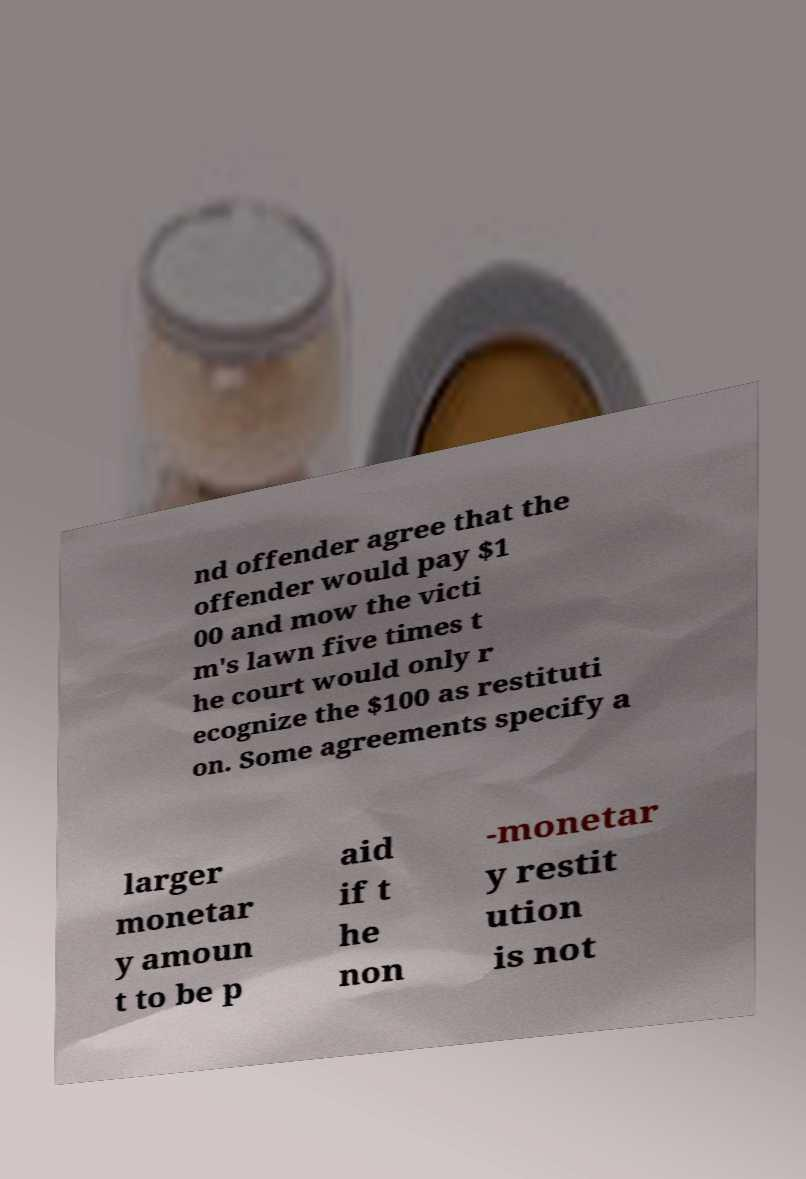What messages or text are displayed in this image? I need them in a readable, typed format. nd offender agree that the offender would pay $1 00 and mow the victi m's lawn five times t he court would only r ecognize the $100 as restituti on. Some agreements specify a larger monetar y amoun t to be p aid if t he non -monetar y restit ution is not 